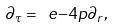<formula> <loc_0><loc_0><loc_500><loc_500>\partial _ { \tau } = \ e { - 4 p } \partial _ { r } ,</formula> 